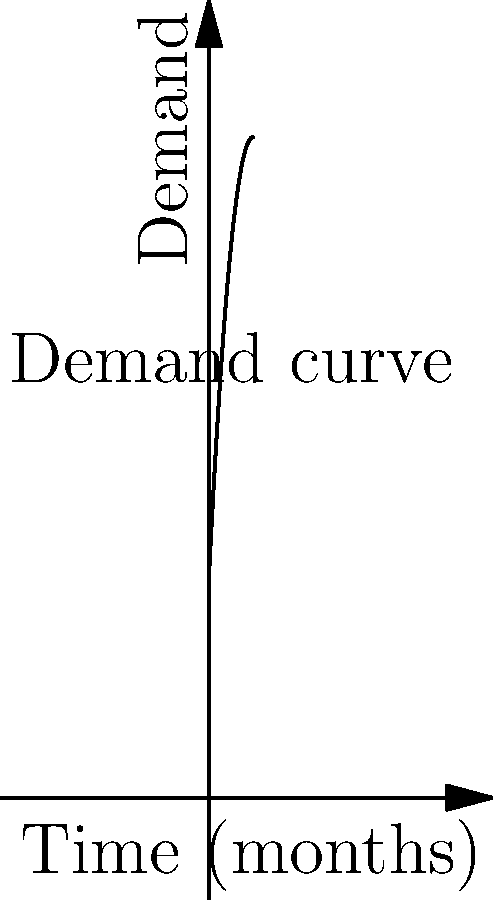As a supply chain manager, you're forecasting the demand for a key ingredient over the next 20 months. The demand function (in units) is given by $D(t) = 100 + 20t - 0.5t^2$, where $t$ is time in months. Calculate the total forecasted demand over the entire 20-month period using the area under the curve. Round your answer to the nearest whole number. To find the total forecasted demand, we need to calculate the area under the curve of the demand function from $t=0$ to $t=20$. This can be done using definite integration:

1) The demand function is $D(t) = 100 + 20t - 0.5t^2$

2) We need to integrate this function from 0 to 20:

   $$\int_0^{20} (100 + 20t - 0.5t^2) dt$$

3) Integrate each term:
   $$\left[100t + 10t^2 - \frac{1}{6}t^3\right]_0^{20}$$

4) Evaluate at the upper and lower bounds:
   $$(2000 + 4000 - \frac{8000}{6}) - (0 + 0 - 0)$$

5) Simplify:
   $$2000 + 4000 - 1333.33 = 4666.67$$

6) Rounding to the nearest whole number:
   4667 units

This represents the total forecasted demand over the 20-month period.
Answer: 4667 units 